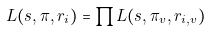Convert formula to latex. <formula><loc_0><loc_0><loc_500><loc_500>L ( s , \pi , r _ { i } ) = \prod L ( s , \pi _ { v } , r _ { i , v } )</formula> 